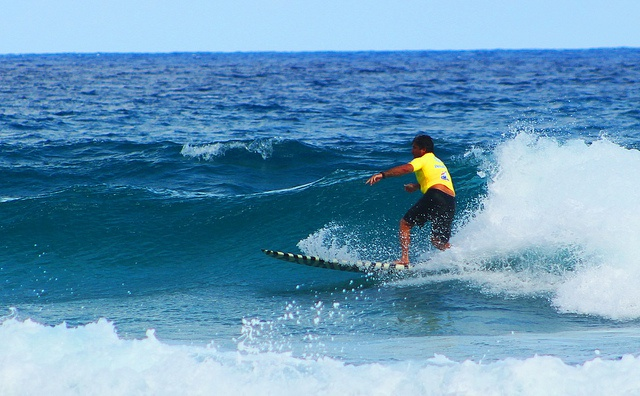Describe the objects in this image and their specific colors. I can see people in lightblue, black, yellow, maroon, and gray tones and surfboard in lightblue, navy, teal, and darkgray tones in this image. 